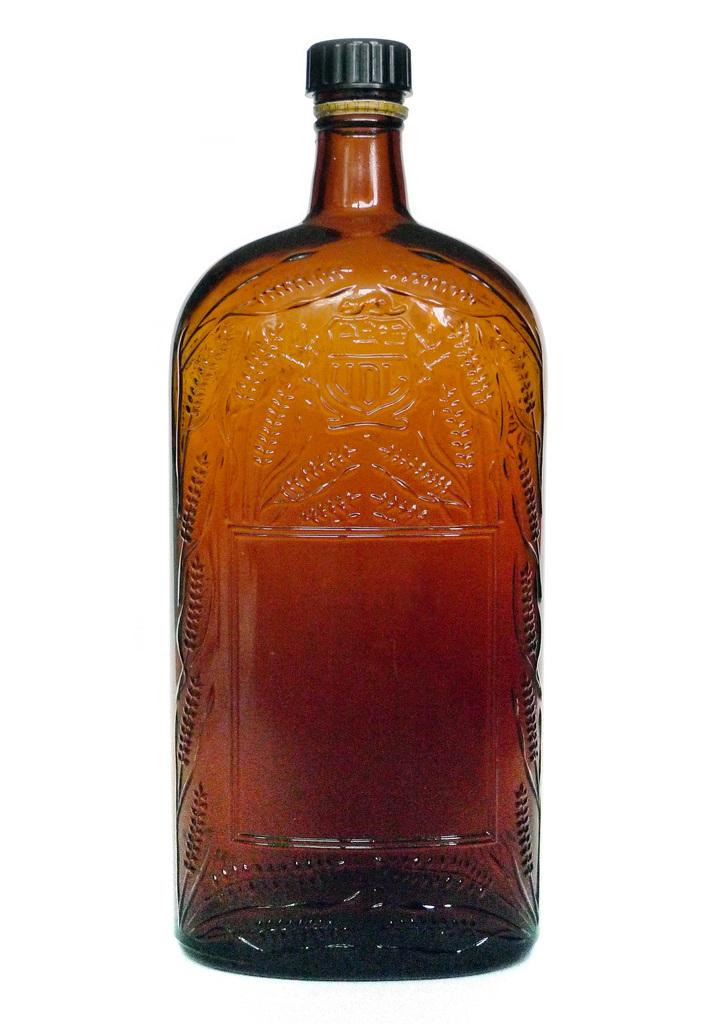What is the main object in the image? There is a bottle in the image. How is the bottle being emphasized in the image? The bottle is highlighted. What color is the cap of the bottle? The bottle has a black cap. How many bridges can be seen crossing the river in the image? There are no bridges or rivers present in the image; it features a bottle with a black cap. What type of division is being performed on the jelly in the image? There is no jelly or division activity present in the image; it features a bottle with a black cap. 